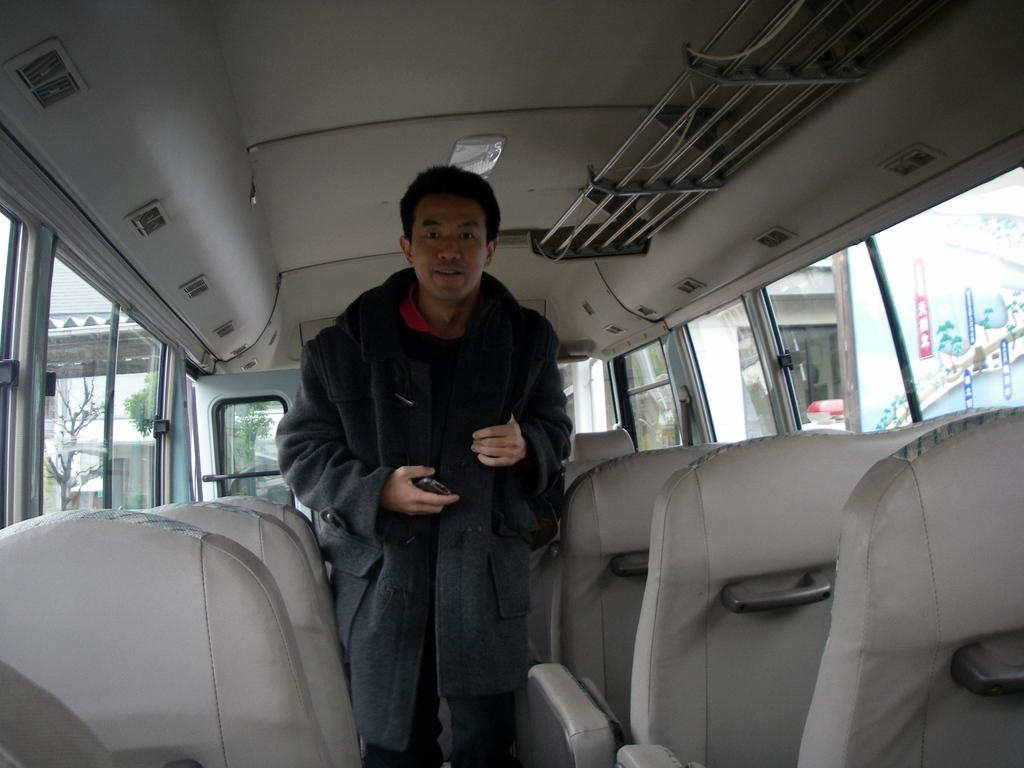What is the man in the image doing? The man is standing in the image and holding an object inside a vehicle. What can be seen through the glass in the image? A building, a shed, trees, and banners can be seen through the glass. What is the man holding inside the vehicle? The facts do not specify what the man is holding inside the vehicle. What type of doll can be seen playing with a balloon in the image? There is no doll or balloon present in the image. 